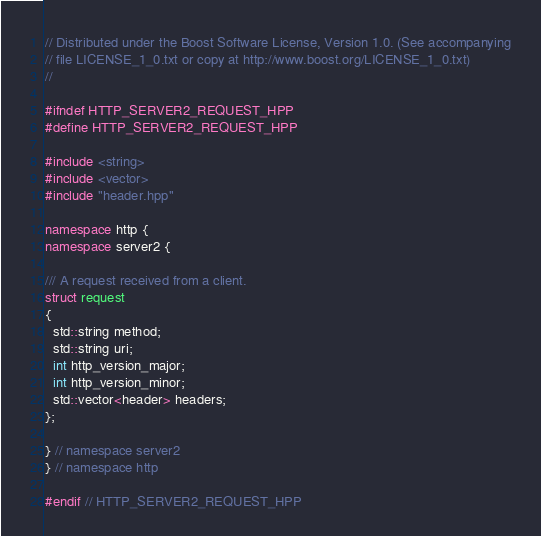<code> <loc_0><loc_0><loc_500><loc_500><_C++_>// Distributed under the Boost Software License, Version 1.0. (See accompanying
// file LICENSE_1_0.txt or copy at http://www.boost.org/LICENSE_1_0.txt)
//

#ifndef HTTP_SERVER2_REQUEST_HPP
#define HTTP_SERVER2_REQUEST_HPP

#include <string>
#include <vector>
#include "header.hpp"

namespace http {
namespace server2 {

/// A request received from a client.
struct request
{
  std::string method;
  std::string uri;
  int http_version_major;
  int http_version_minor;
  std::vector<header> headers;
};

} // namespace server2
} // namespace http

#endif // HTTP_SERVER2_REQUEST_HPP
</code> 